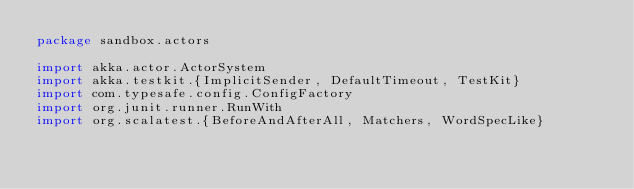Convert code to text. <code><loc_0><loc_0><loc_500><loc_500><_Scala_>package sandbox.actors

import akka.actor.ActorSystem
import akka.testkit.{ImplicitSender, DefaultTimeout, TestKit}
import com.typesafe.config.ConfigFactory
import org.junit.runner.RunWith
import org.scalatest.{BeforeAndAfterAll, Matchers, WordSpecLike}</code> 